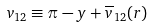<formula> <loc_0><loc_0><loc_500><loc_500>v _ { 1 2 } \equiv \pi - y + { \overline { v } _ { 1 2 } } ( r )</formula> 